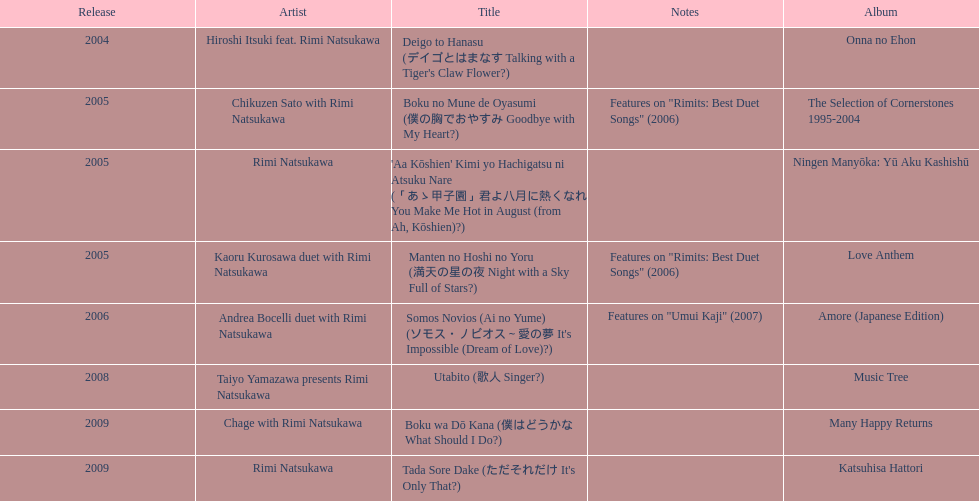How many albums has artist rimi natsukawa released? 8. Could you help me parse every detail presented in this table? {'header': ['Release', 'Artist', 'Title', 'Notes', 'Album'], 'rows': [['2004', 'Hiroshi Itsuki feat. Rimi Natsukawa', "Deigo to Hanasu (デイゴとはまなす Talking with a Tiger's Claw Flower?)", '', 'Onna no Ehon'], ['2005', 'Chikuzen Sato with Rimi Natsukawa', 'Boku no Mune de Oyasumi (僕の胸でおやすみ Goodbye with My Heart?)', 'Features on "Rimits: Best Duet Songs" (2006)', 'The Selection of Cornerstones 1995-2004'], ['2005', 'Rimi Natsukawa', "'Aa Kōshien' Kimi yo Hachigatsu ni Atsuku Nare (「あゝ甲子園」君よ八月に熱くなれ You Make Me Hot in August (from Ah, Kōshien)?)", '', 'Ningen Manyōka: Yū Aku Kashishū'], ['2005', 'Kaoru Kurosawa duet with Rimi Natsukawa', 'Manten no Hoshi no Yoru (満天の星の夜 Night with a Sky Full of Stars?)', 'Features on "Rimits: Best Duet Songs" (2006)', 'Love Anthem'], ['2006', 'Andrea Bocelli duet with Rimi Natsukawa', "Somos Novios (Ai no Yume) (ソモス・ノビオス～愛の夢 It's Impossible (Dream of Love)?)", 'Features on "Umui Kaji" (2007)', 'Amore (Japanese Edition)'], ['2008', 'Taiyo Yamazawa presents Rimi Natsukawa', 'Utabito (歌人 Singer?)', '', 'Music Tree'], ['2009', 'Chage with Rimi Natsukawa', 'Boku wa Dō Kana (僕はどうかな What Should I Do?)', '', 'Many Happy Returns'], ['2009', 'Rimi Natsukawa', "Tada Sore Dake (ただそれだけ It's Only That?)", '', 'Katsuhisa Hattori']]} 